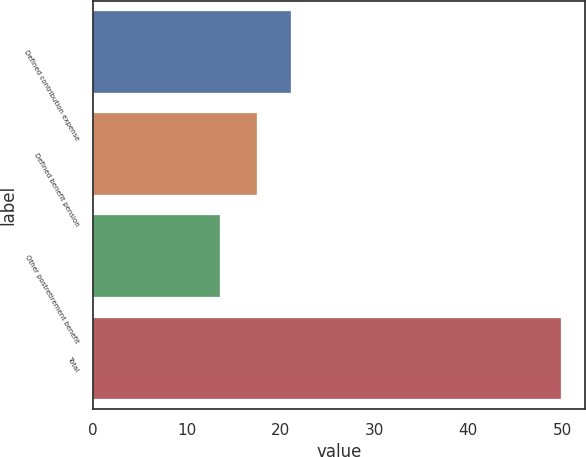Convert chart to OTSL. <chart><loc_0><loc_0><loc_500><loc_500><bar_chart><fcel>Defined contribution expense<fcel>Defined benefit pension<fcel>Other postretirement benefit<fcel>Total<nl><fcel>21.14<fcel>17.5<fcel>13.5<fcel>49.9<nl></chart> 